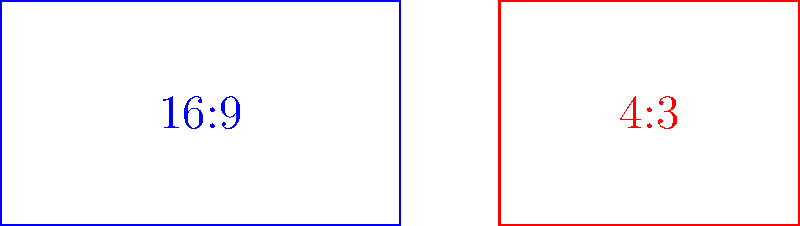In cinematic arts, aspect ratios are crucial for framing and composition. The diagram shows two common aspect ratios: 16:9 (widescreen) and 4:3 (standard). If a film shot in 16:9 format has a width of 1920 pixels, what would be the width of the same image when cropped to a 4:3 aspect ratio while maintaining the original height? Let's approach this step-by-step:

1) First, we need to calculate the height of the 16:9 image:
   $$\frac{width}{height} = \frac{16}{9}$$
   $$\frac{1920}{height} = \frac{16}{9}$$
   $$height = 1920 \cdot \frac{9}{16} = 1080 \text{ pixels}$$

2) Now we know the original image is 1920x1080 pixels.

3) We want to maintain this height (1080 pixels) but change the aspect ratio to 4:3.

4) The aspect ratio formula for 4:3 is:
   $$\frac{width}{1080} = \frac{4}{3}$$

5) Solving for width:
   $$width = 1080 \cdot \frac{4}{3} = 1440 \text{ pixels}$$

Therefore, to maintain the same height but change to a 4:3 aspect ratio, the width needs to be 1440 pixels.
Answer: 1440 pixels 